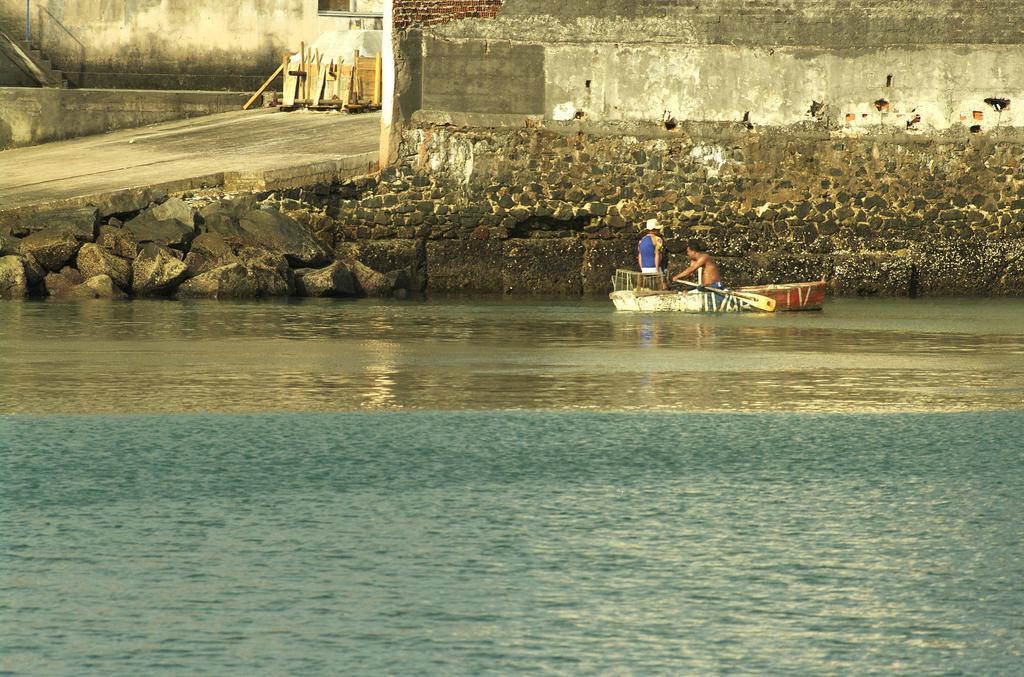In one or two sentences, can you explain what this image depicts? In this image there is water at the bottom. There are stones, there are steps, wooden objects on the left corner. There are people, it looks like a boat, there is an object and there is a stone wall in the background. 